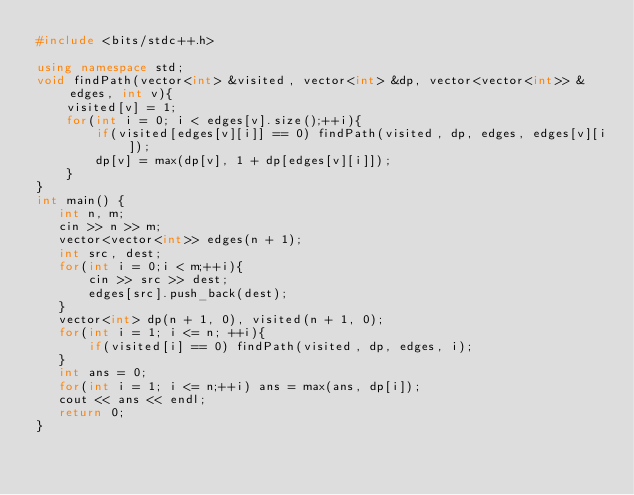Convert code to text. <code><loc_0><loc_0><loc_500><loc_500><_C++_>#include <bits/stdc++.h>

using namespace std;
void findPath(vector<int> &visited, vector<int> &dp, vector<vector<int>> &edges, int v){
    visited[v] = 1;
    for(int i = 0; i < edges[v].size();++i){
        if(visited[edges[v][i]] == 0) findPath(visited, dp, edges, edges[v][i]);
        dp[v] = max(dp[v], 1 + dp[edges[v][i]]);
    }
}
int main() {
   int n, m;
   cin >> n >> m;
   vector<vector<int>> edges(n + 1);
   int src, dest;
   for(int i = 0;i < m;++i){
       cin >> src >> dest;
       edges[src].push_back(dest);
   }
   vector<int> dp(n + 1, 0), visited(n + 1, 0);
   for(int i = 1; i <= n; ++i){
       if(visited[i] == 0) findPath(visited, dp, edges, i);
   }
   int ans = 0;
   for(int i = 1; i <= n;++i) ans = max(ans, dp[i]);
   cout << ans << endl;
   return 0;
}</code> 